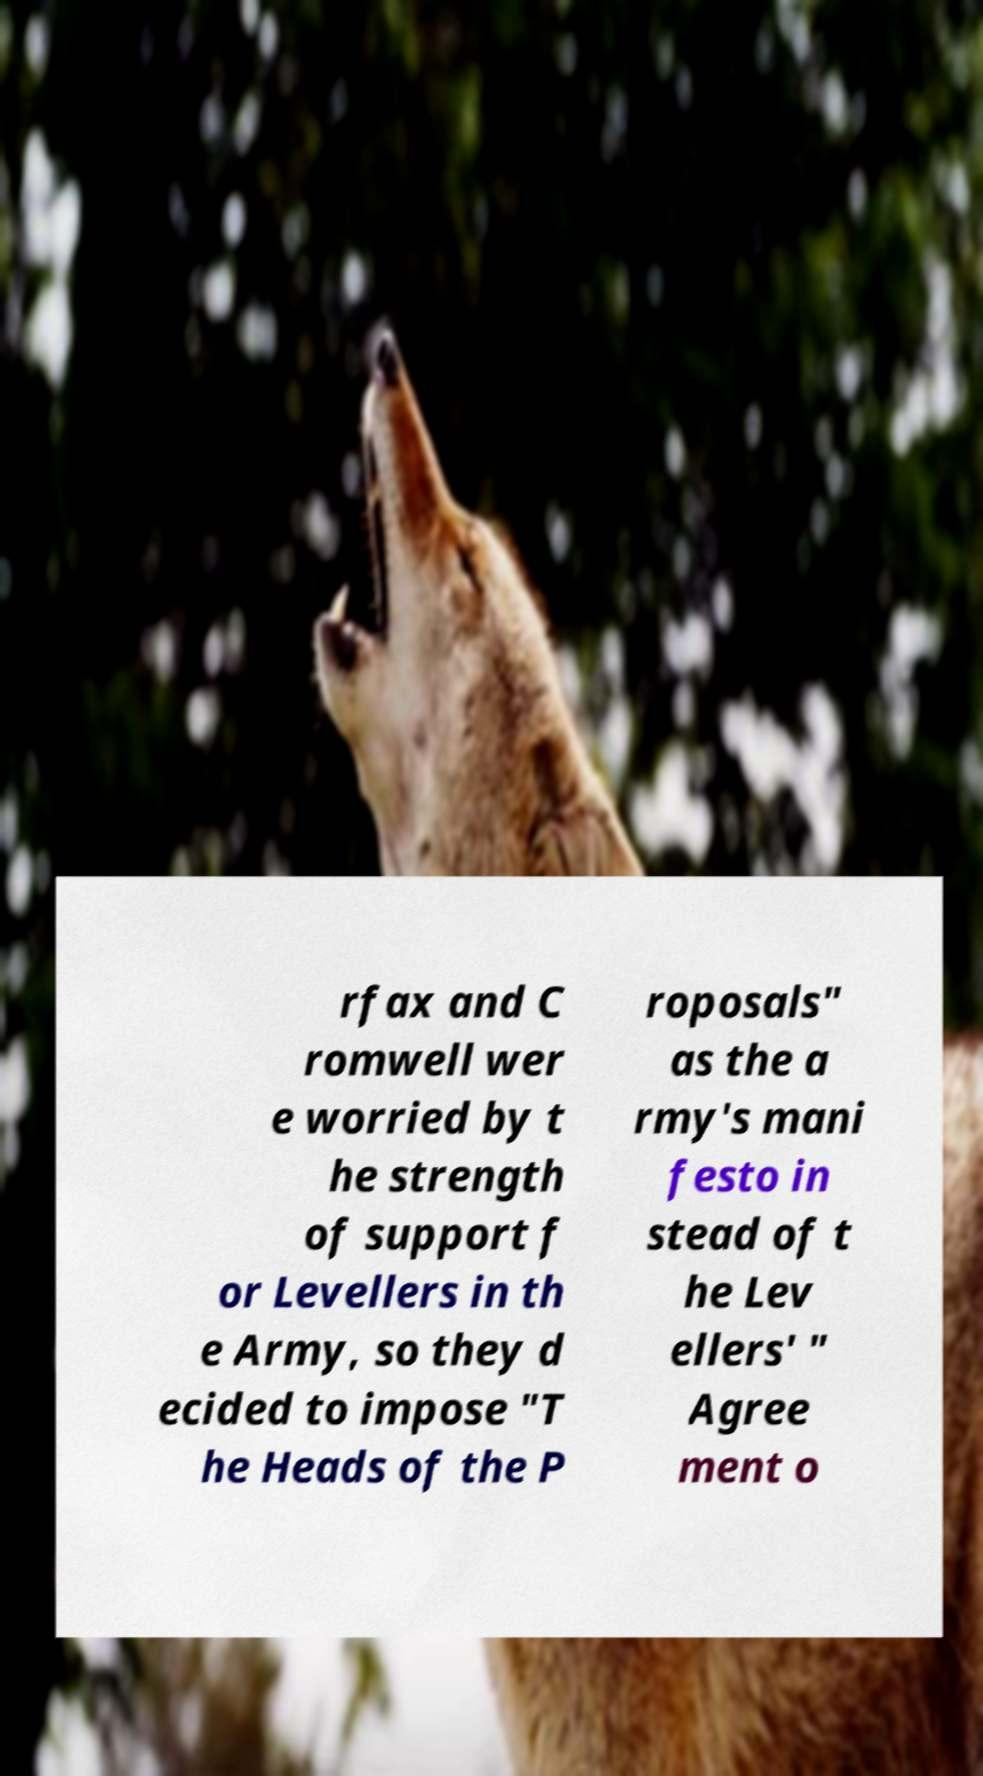I need the written content from this picture converted into text. Can you do that? rfax and C romwell wer e worried by t he strength of support f or Levellers in th e Army, so they d ecided to impose "T he Heads of the P roposals" as the a rmy's mani festo in stead of t he Lev ellers' " Agree ment o 